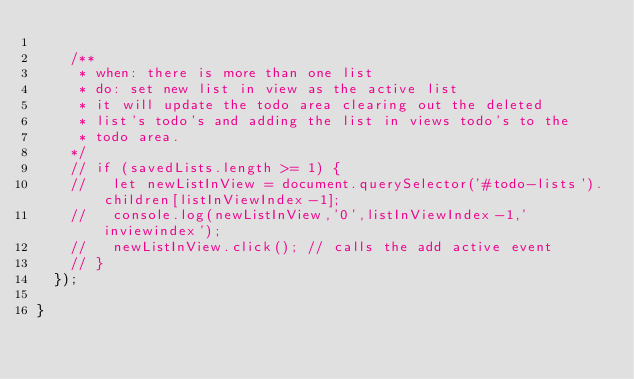<code> <loc_0><loc_0><loc_500><loc_500><_JavaScript_>
    /**
     * when: there is more than one list
     * do: set new list in view as the active list
     * it will update the todo area clearing out the deleted
     * list's todo's and adding the list in views todo's to the
     * todo area.
    */
    // if (savedLists.length >= 1) {
    //   let newListInView = document.querySelector('#todo-lists').children[listInViewIndex-1];
    //   console.log(newListInView,'0',listInViewIndex-1,'inviewindex');
    //   newListInView.click(); // calls the add active event
    // }
  });

}</code> 